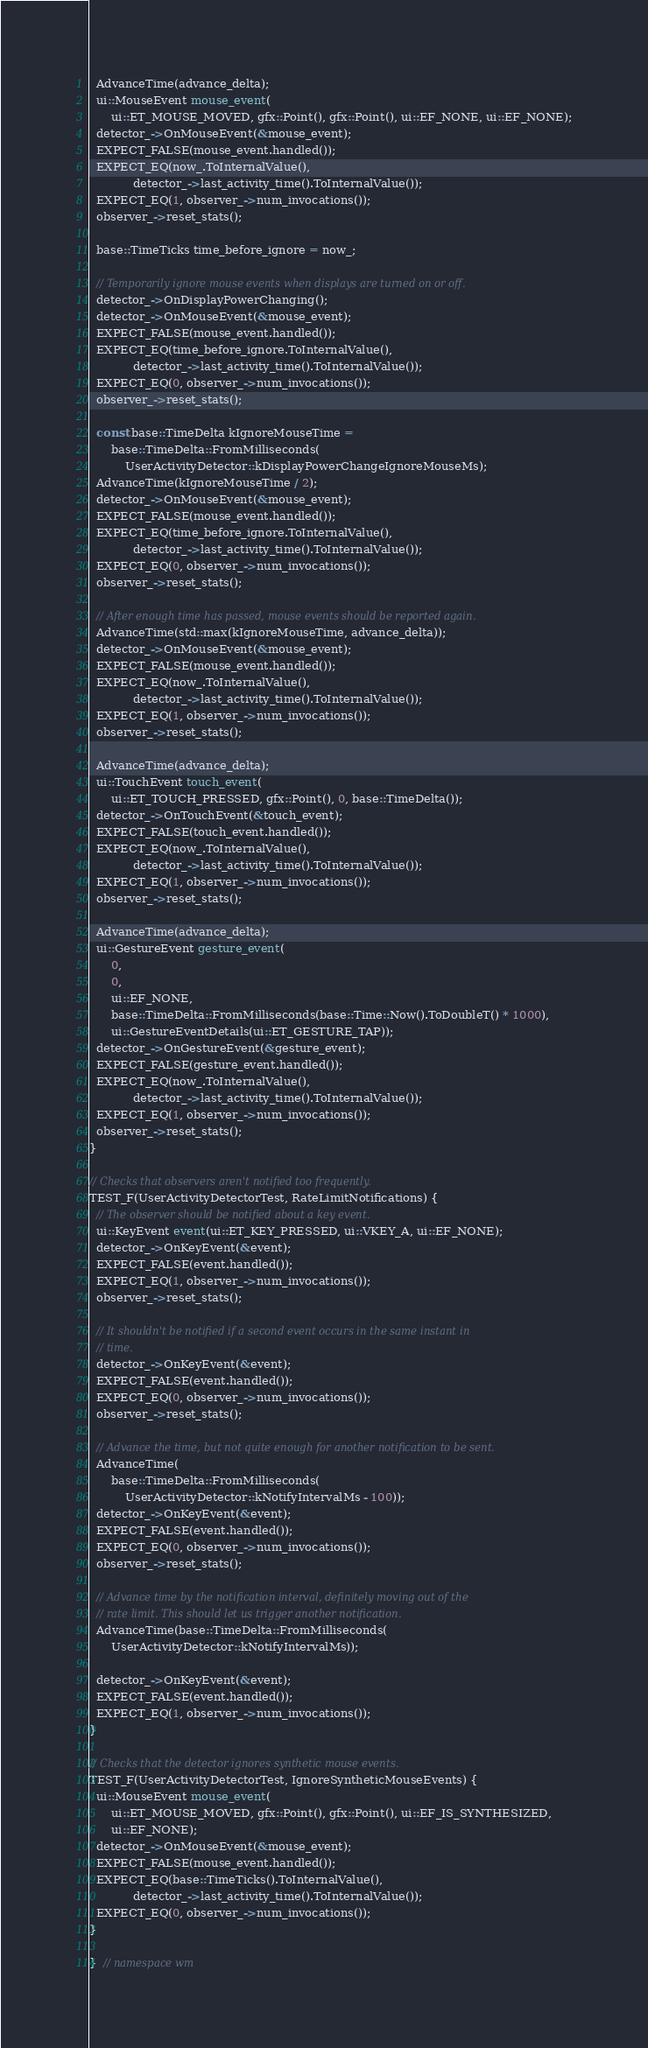<code> <loc_0><loc_0><loc_500><loc_500><_C++_>  AdvanceTime(advance_delta);
  ui::MouseEvent mouse_event(
      ui::ET_MOUSE_MOVED, gfx::Point(), gfx::Point(), ui::EF_NONE, ui::EF_NONE);
  detector_->OnMouseEvent(&mouse_event);
  EXPECT_FALSE(mouse_event.handled());
  EXPECT_EQ(now_.ToInternalValue(),
            detector_->last_activity_time().ToInternalValue());
  EXPECT_EQ(1, observer_->num_invocations());
  observer_->reset_stats();

  base::TimeTicks time_before_ignore = now_;

  // Temporarily ignore mouse events when displays are turned on or off.
  detector_->OnDisplayPowerChanging();
  detector_->OnMouseEvent(&mouse_event);
  EXPECT_FALSE(mouse_event.handled());
  EXPECT_EQ(time_before_ignore.ToInternalValue(),
            detector_->last_activity_time().ToInternalValue());
  EXPECT_EQ(0, observer_->num_invocations());
  observer_->reset_stats();

  const base::TimeDelta kIgnoreMouseTime =
      base::TimeDelta::FromMilliseconds(
          UserActivityDetector::kDisplayPowerChangeIgnoreMouseMs);
  AdvanceTime(kIgnoreMouseTime / 2);
  detector_->OnMouseEvent(&mouse_event);
  EXPECT_FALSE(mouse_event.handled());
  EXPECT_EQ(time_before_ignore.ToInternalValue(),
            detector_->last_activity_time().ToInternalValue());
  EXPECT_EQ(0, observer_->num_invocations());
  observer_->reset_stats();

  // After enough time has passed, mouse events should be reported again.
  AdvanceTime(std::max(kIgnoreMouseTime, advance_delta));
  detector_->OnMouseEvent(&mouse_event);
  EXPECT_FALSE(mouse_event.handled());
  EXPECT_EQ(now_.ToInternalValue(),
            detector_->last_activity_time().ToInternalValue());
  EXPECT_EQ(1, observer_->num_invocations());
  observer_->reset_stats();

  AdvanceTime(advance_delta);
  ui::TouchEvent touch_event(
      ui::ET_TOUCH_PRESSED, gfx::Point(), 0, base::TimeDelta());
  detector_->OnTouchEvent(&touch_event);
  EXPECT_FALSE(touch_event.handled());
  EXPECT_EQ(now_.ToInternalValue(),
            detector_->last_activity_time().ToInternalValue());
  EXPECT_EQ(1, observer_->num_invocations());
  observer_->reset_stats();

  AdvanceTime(advance_delta);
  ui::GestureEvent gesture_event(
      0,
      0,
      ui::EF_NONE,
      base::TimeDelta::FromMilliseconds(base::Time::Now().ToDoubleT() * 1000),
      ui::GestureEventDetails(ui::ET_GESTURE_TAP));
  detector_->OnGestureEvent(&gesture_event);
  EXPECT_FALSE(gesture_event.handled());
  EXPECT_EQ(now_.ToInternalValue(),
            detector_->last_activity_time().ToInternalValue());
  EXPECT_EQ(1, observer_->num_invocations());
  observer_->reset_stats();
}

// Checks that observers aren't notified too frequently.
TEST_F(UserActivityDetectorTest, RateLimitNotifications) {
  // The observer should be notified about a key event.
  ui::KeyEvent event(ui::ET_KEY_PRESSED, ui::VKEY_A, ui::EF_NONE);
  detector_->OnKeyEvent(&event);
  EXPECT_FALSE(event.handled());
  EXPECT_EQ(1, observer_->num_invocations());
  observer_->reset_stats();

  // It shouldn't be notified if a second event occurs in the same instant in
  // time.
  detector_->OnKeyEvent(&event);
  EXPECT_FALSE(event.handled());
  EXPECT_EQ(0, observer_->num_invocations());
  observer_->reset_stats();

  // Advance the time, but not quite enough for another notification to be sent.
  AdvanceTime(
      base::TimeDelta::FromMilliseconds(
          UserActivityDetector::kNotifyIntervalMs - 100));
  detector_->OnKeyEvent(&event);
  EXPECT_FALSE(event.handled());
  EXPECT_EQ(0, observer_->num_invocations());
  observer_->reset_stats();

  // Advance time by the notification interval, definitely moving out of the
  // rate limit. This should let us trigger another notification.
  AdvanceTime(base::TimeDelta::FromMilliseconds(
      UserActivityDetector::kNotifyIntervalMs));

  detector_->OnKeyEvent(&event);
  EXPECT_FALSE(event.handled());
  EXPECT_EQ(1, observer_->num_invocations());
}

// Checks that the detector ignores synthetic mouse events.
TEST_F(UserActivityDetectorTest, IgnoreSyntheticMouseEvents) {
  ui::MouseEvent mouse_event(
      ui::ET_MOUSE_MOVED, gfx::Point(), gfx::Point(), ui::EF_IS_SYNTHESIZED,
      ui::EF_NONE);
  detector_->OnMouseEvent(&mouse_event);
  EXPECT_FALSE(mouse_event.handled());
  EXPECT_EQ(base::TimeTicks().ToInternalValue(),
            detector_->last_activity_time().ToInternalValue());
  EXPECT_EQ(0, observer_->num_invocations());
}

}  // namespace wm
</code> 